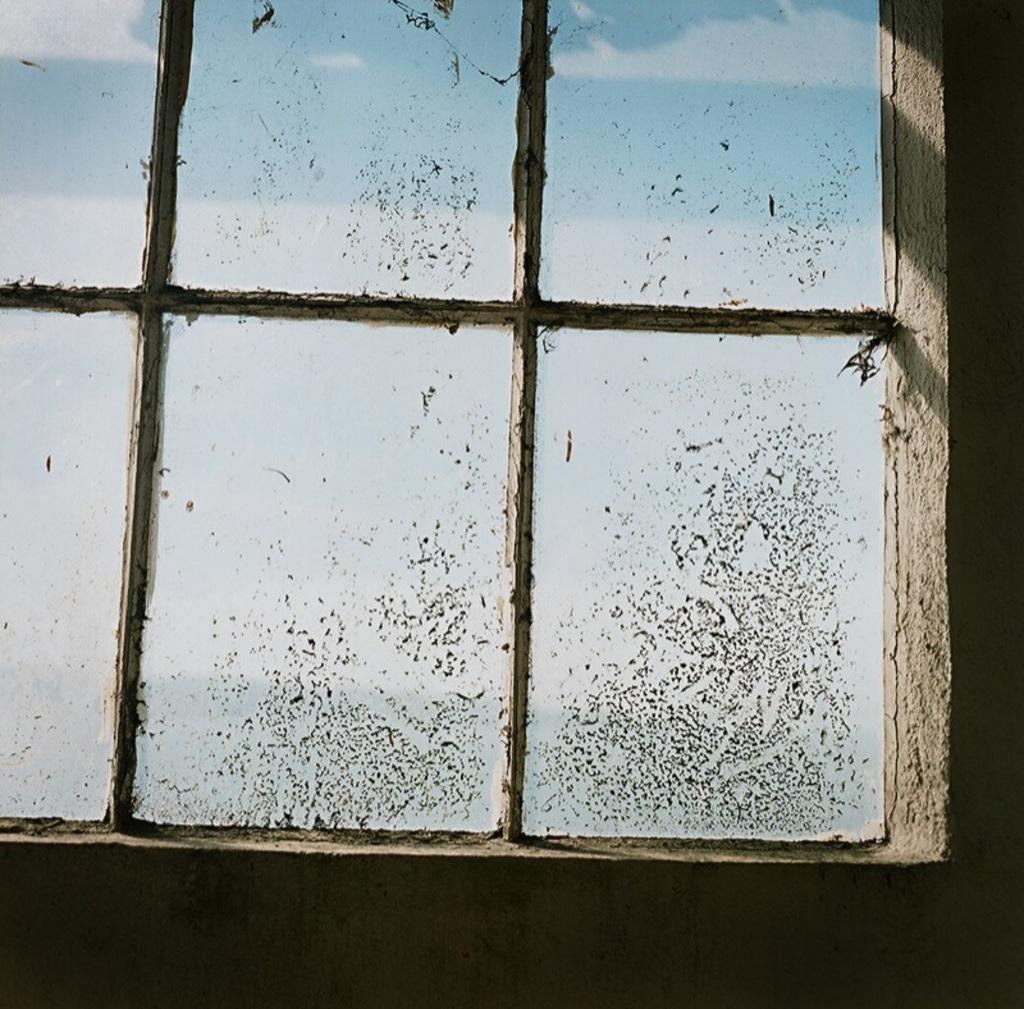What type of structure can be seen in the image? There is a wall in the image. What is a feature of the wall in the image? There is a glass window in the image. Can you describe the condition of the glass window? Dust is visible on the glass. What type of jewel is placed on the sofa in the image? There is no sofa or jewel present in the image; it only features a wall and a glass window with dust on it. 